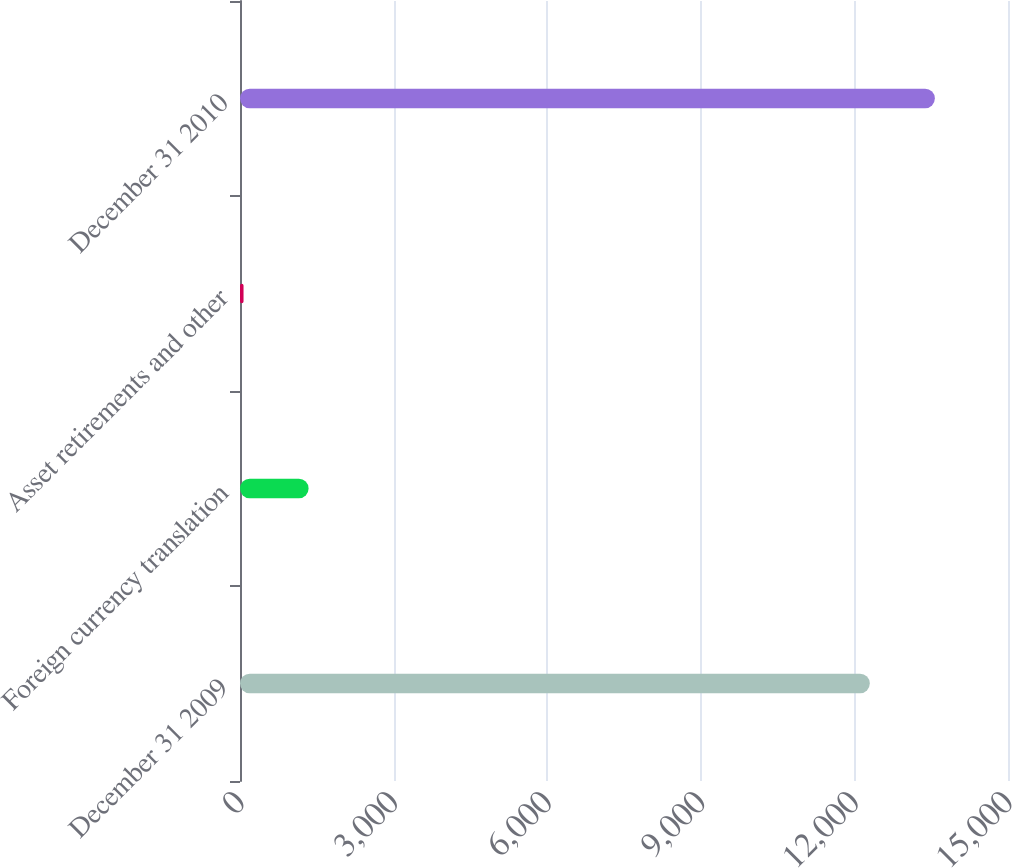Convert chart to OTSL. <chart><loc_0><loc_0><loc_500><loc_500><bar_chart><fcel>December 31 2009<fcel>Foreign currency translation<fcel>Asset retirements and other<fcel>December 31 2010<nl><fcel>12301<fcel>1339.8<fcel>69<fcel>13571.8<nl></chart> 